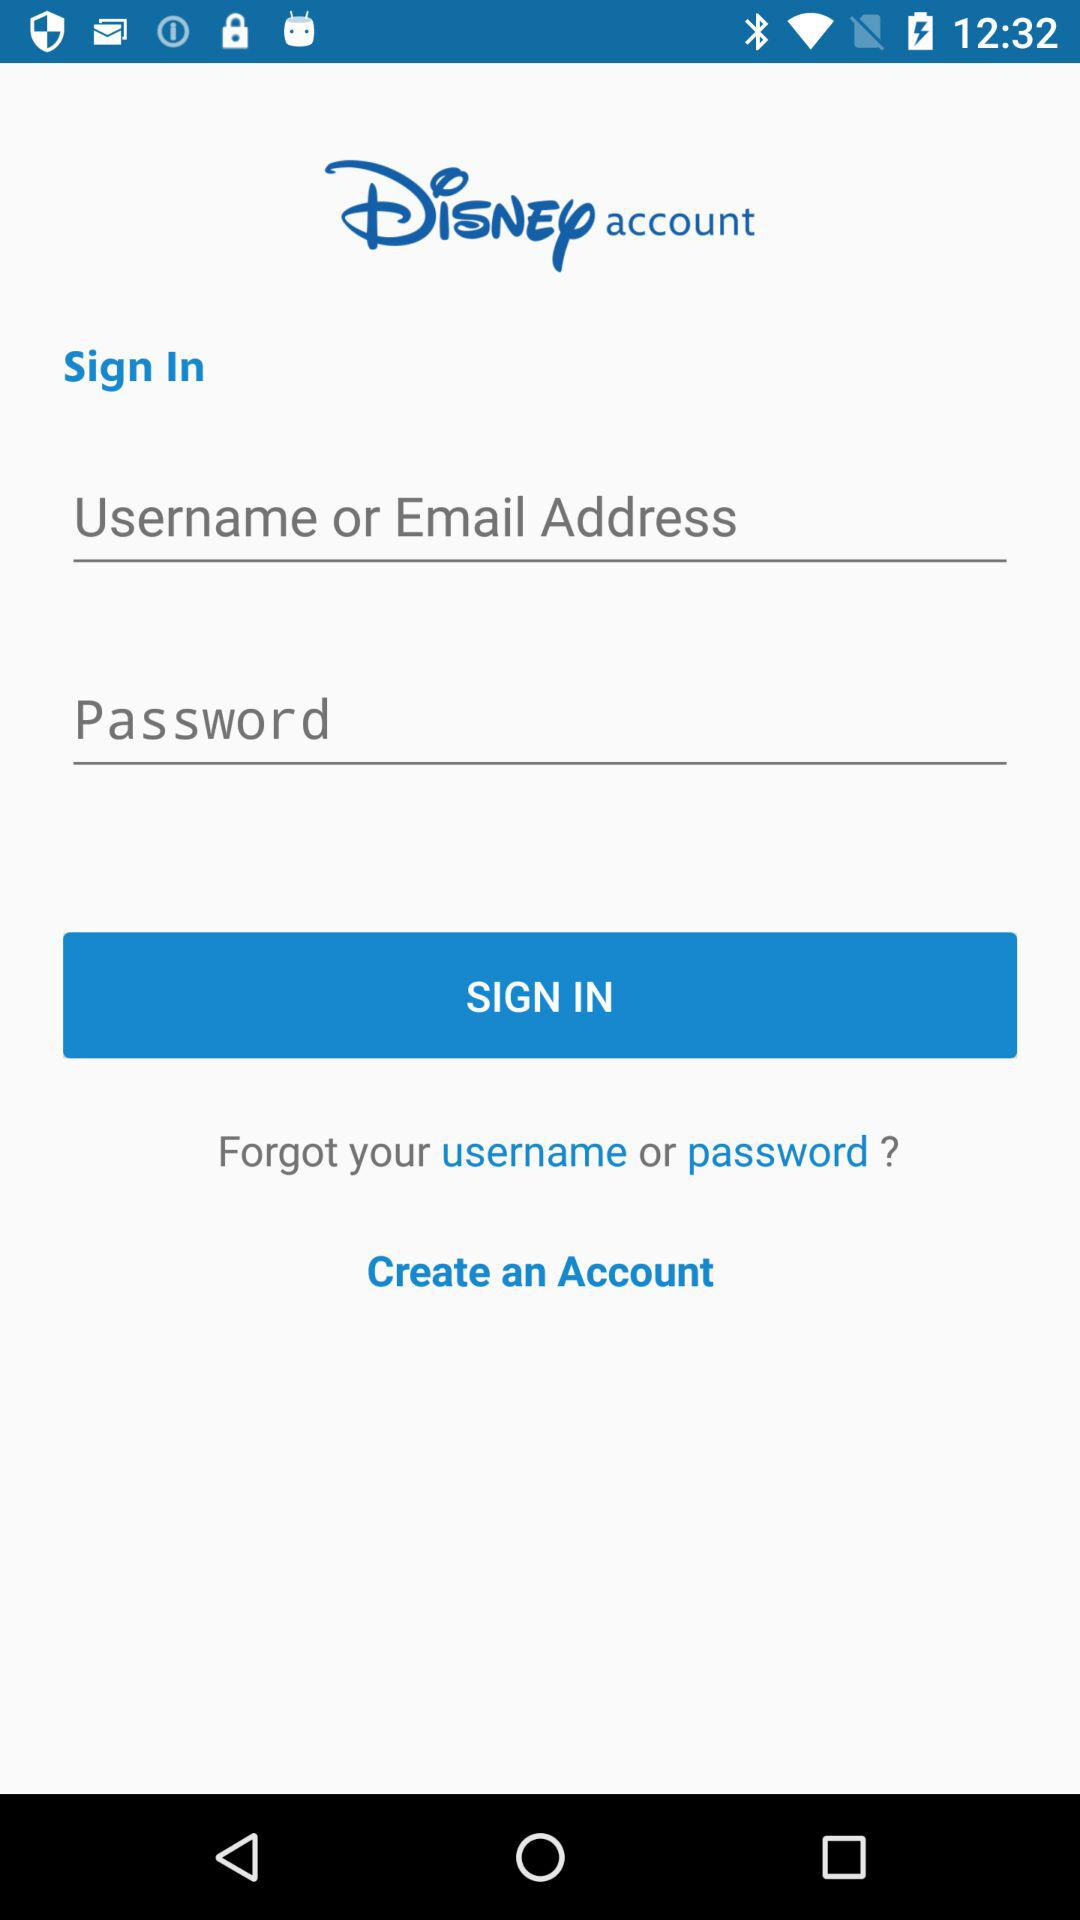Can we reset password?
When the provided information is insufficient, respond with <no answer>. <no answer> 